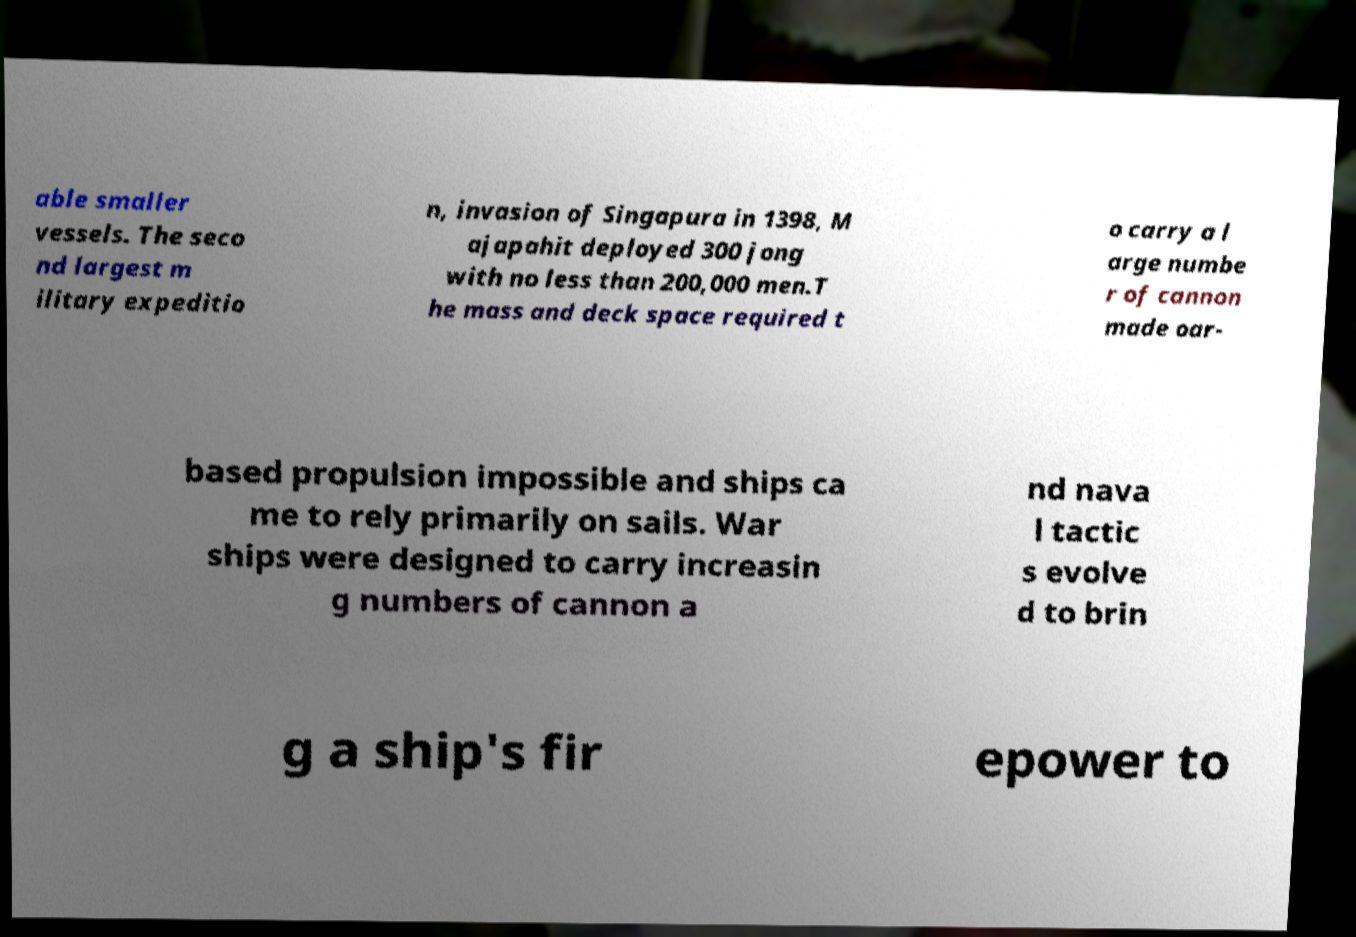Could you assist in decoding the text presented in this image and type it out clearly? able smaller vessels. The seco nd largest m ilitary expeditio n, invasion of Singapura in 1398, M ajapahit deployed 300 jong with no less than 200,000 men.T he mass and deck space required t o carry a l arge numbe r of cannon made oar- based propulsion impossible and ships ca me to rely primarily on sails. War ships were designed to carry increasin g numbers of cannon a nd nava l tactic s evolve d to brin g a ship's fir epower to 